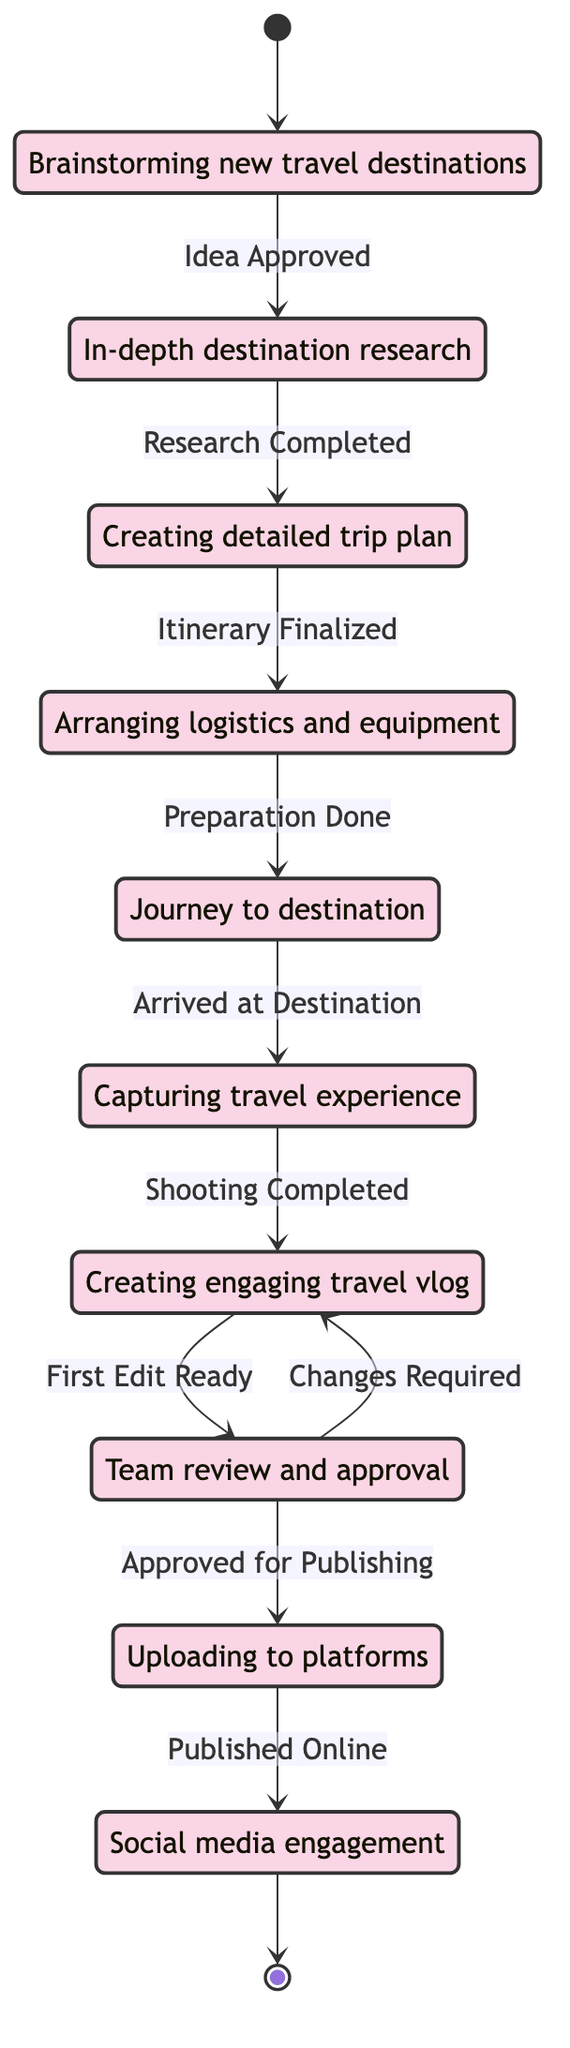What is the first state in the workflow? The first state in the workflow is indicated by the initial transition from the starting point to the "IdeaGeneration" state. The diagram specifies that the process begins here.
Answer: IdeaGeneration How many total states are in the workflow? By counting the different state nodes represented in the diagram, we find there are ten unique states: IdeaGeneration, Research, ItineraryPlanning, PreTravelPreparation, Travel, Shooting, Editing, Review, Publishing, and Promotion.
Answer: 10 What action leads from "Research" to "ItineraryPlanning"? The transition from "Research" to "ItineraryPlanning" is marked by the action labeled as "Research Completed", which indicates that after the research phase is done, the process moves to itinerary planning.
Answer: Research Completed Which state comes after "Shooting"? Following the "Shooting" state, the next transition leads to the "Editing" state. The diagram shows that after shooting is completed, editing of the footage begins.
Answer: Editing What is the last state in the workflow? The last state in the workflow is indicated by the flow leading from "Publishing" to "Promotion" and then to the end point of the diagram, showing that promotion is the last activity conducted after publishing.
Answer: Promotion What action must be taken before traveling can begin? Before moving to "Travel", the necessary action that must be completed is "Preparation Done", which follows the "PreTravelPreparation" state, indicating all pre-travel arrangements need to be finalized beforehand.
Answer: Preparation Done What state represents the final check before publishing? The state that serves as the final check before the content is published is the "Review" state, where the edited video is reviewed by the team for any necessary changes.
Answer: Review How many transitions are there from "Editing"? There are two transitions from the "Editing" state: one to "Review" marked by "First Edit Ready", and another back to "Editing" if "Changes Required" are identified during the review process. Thus, there are two transitions.
Answer: 2 What triggers the transition from "Review" to "Publishing"? The transition from "Review" to "Publishing" is triggered by the action labeled "Approved for Publishing", indicating that once the video is approved, it can be published.
Answer: Approved for Publishing 